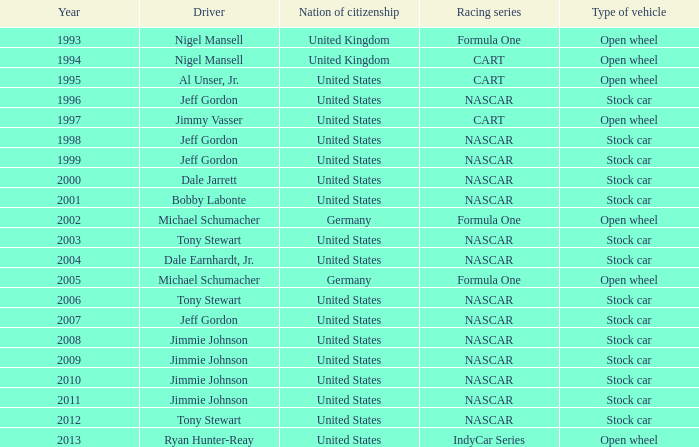What year has the vehicle of open wheel and a racing series of formula one with a Nation of citizenship in Germany. 2002, 2005. 